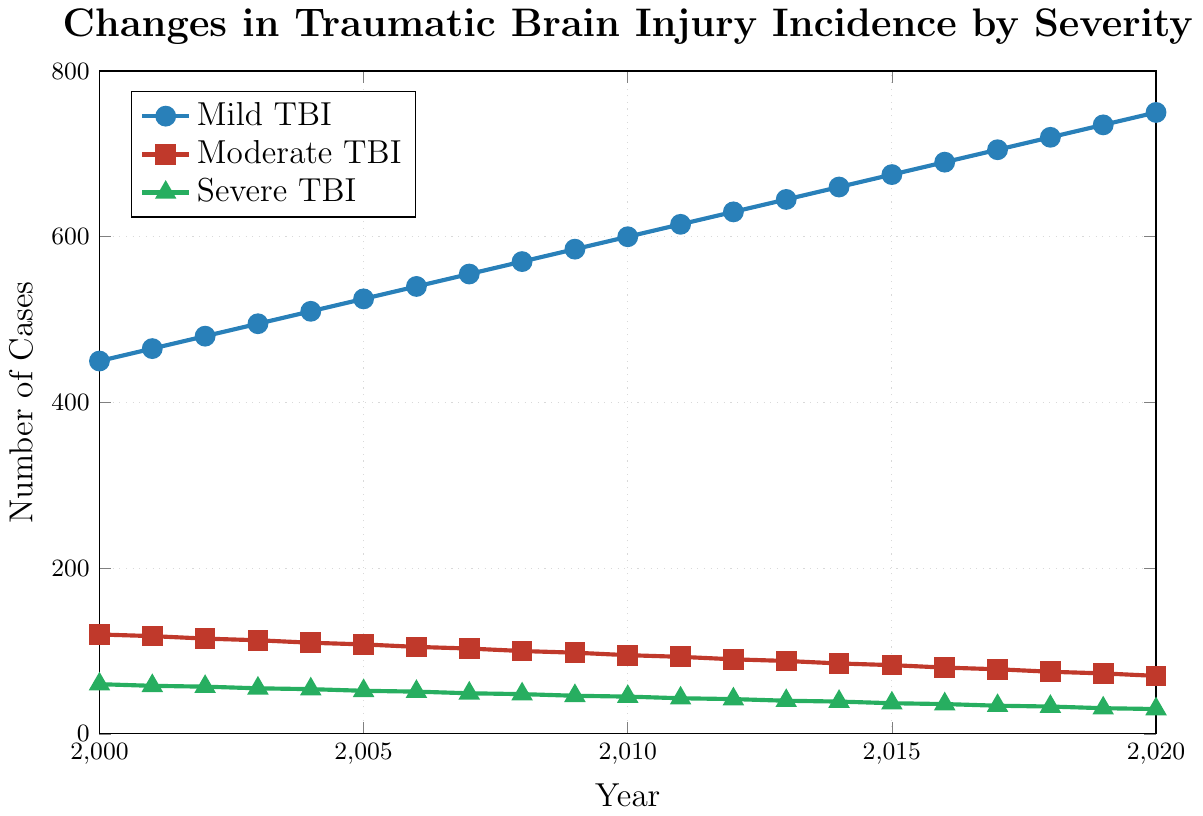What general trend can be observed in the number of Mild TBIs from 2000 to 2020? The number of Mild TBIs increases steadily from 450 in 2000 to 750 in 2020. This is evident from the upward trajectory of the blue line representing Mild TBIs.
Answer: Increasing How did the number of Moderate TBIs change from 2000 to 2020? The number of Moderate TBIs decreases from 120 in 2000 to 70 in 2020. This is clear from the downward slope of the red line signifying Moderate TBIs in the plot.
Answer: Decreasing In which year did Severe TBIs reach their lowest level, and what was the number? By examining the green line representing Severe TBIs, the lowest level is reached in 2020, with 30 cases.
Answer: 2020, 30 By how much did the number of Mild TBIs increase from 2005 to 2015? The number of Mild TBIs was 525 in 2005 and increased to 675 in 2015. The increase is 675 - 525 = 150.
Answer: 150 Compare the rates of decrease in the number of Severe and Moderate TBIs from 2000 to 2020. Which one decreased more rapidly in terms of absolute value? Severe TBIs decreased from 60 in 2000 to 30 in 2020, a change of -30. Moderate TBIs decreased from 120 in 2000 to 70 in 2020, a change of -50. Even though both categories show a downward trend, Moderate TBIs decreased more rapidly by an absolute value of 50 compared to 30 for Severe TBIs.
Answer: Moderate TBIs What are the respective values of the three types of TBIs in the year 2010? In 2010, the values for Mild, Moderate, and Severe TBIs are represented by the points on their respective lines at the year 2010: Mild TBI is 600, Moderate TBI is 95, and Severe TBI is 45.
Answer: Mild: 600, Moderate: 95, Severe: 45 What is the average number of Severe TBIs from 2000 to 2020? The average number of Severe TBIs can be calculated by summing up the values from each year (60+58+57+55+54+52+51+49+48+46+45+43+42+40+39+37+36+34+33+31+30 = 983) and dividing by the number of years (21). This results in an average of 983 / 21 ≈ 46.8.
Answer: 46.8 In what year did the number of Mild TBIs first exceed 600 cases? The blue line representing Mild TBIs first surpasses the 600-case mark at the year 2011, where the data point is 615 cases.
Answer: 2011 What was the numerical difference between the values for Mild and Moderate TBIs in 2015? The value for Mild TBIs in 2015 is 675, and for Moderate TBIs, it is 83. The difference is 675 - 83 = 592.
Answer: 592 